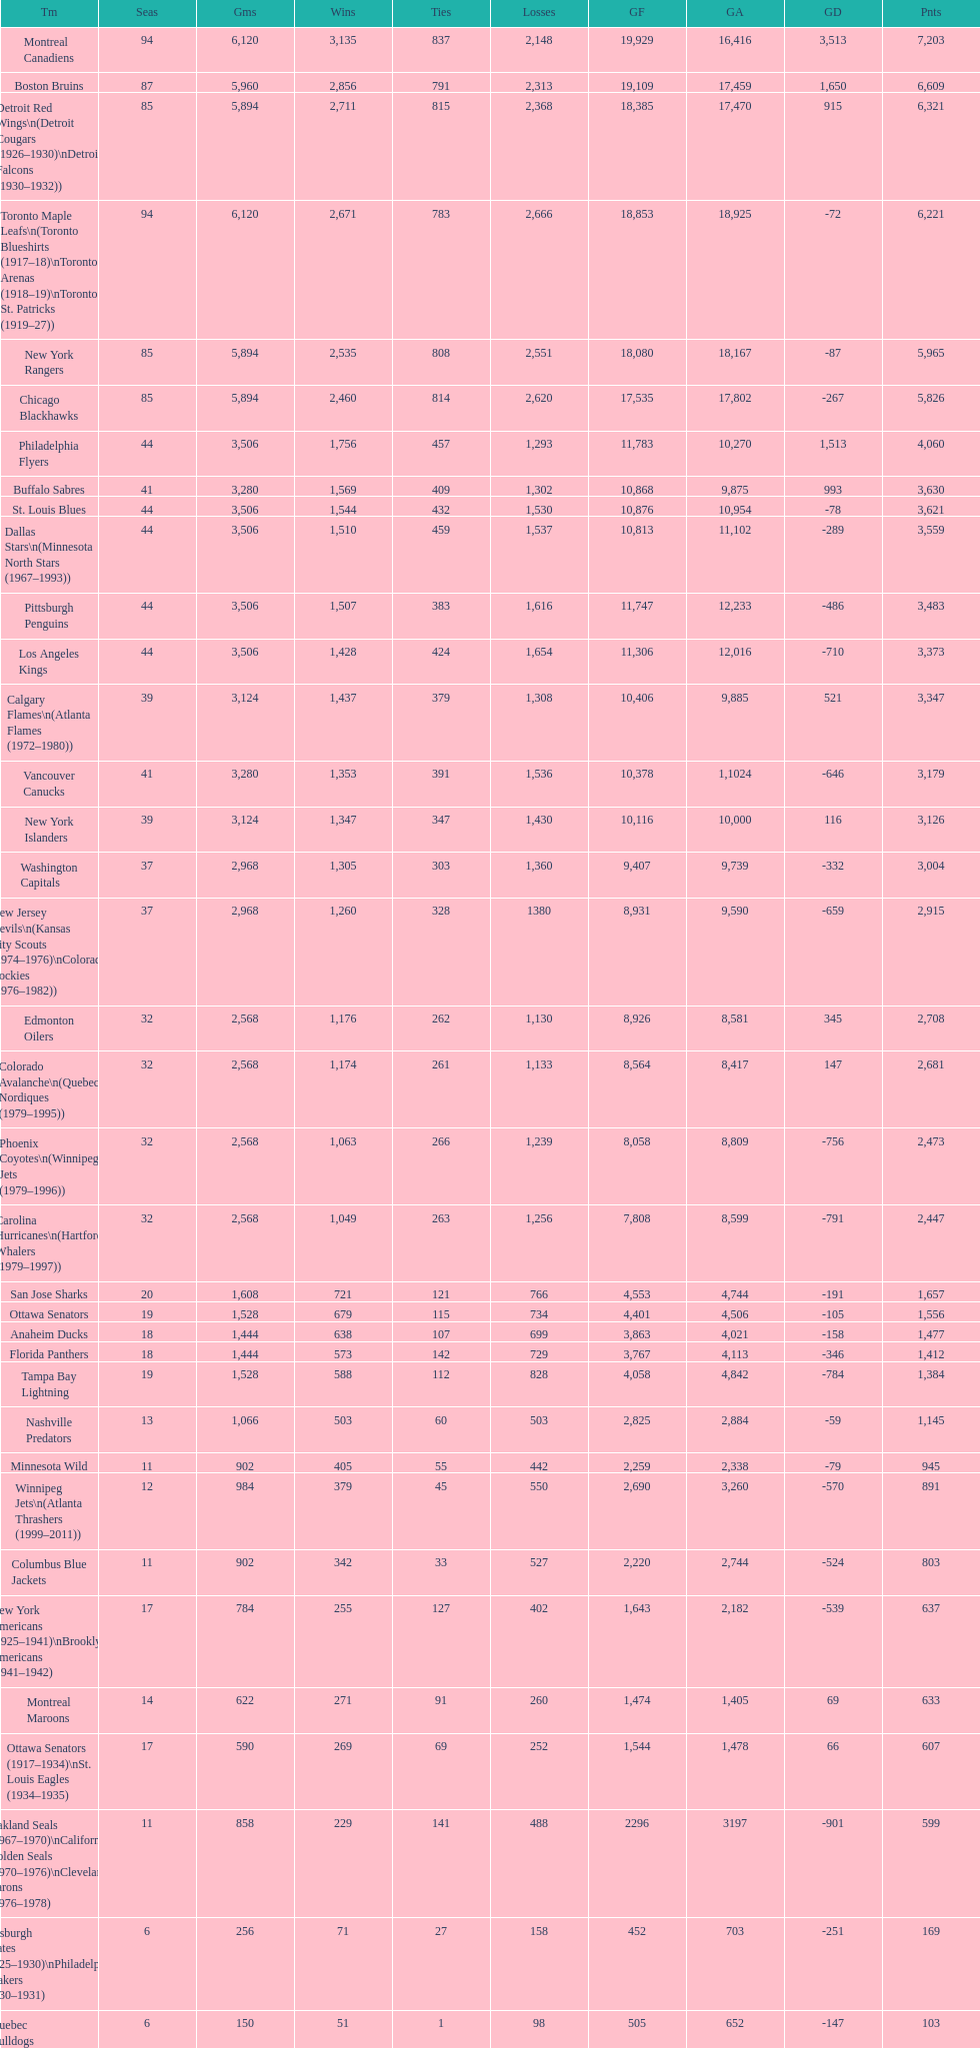Which team played the same amount of seasons as the canadiens? Toronto Maple Leafs. 